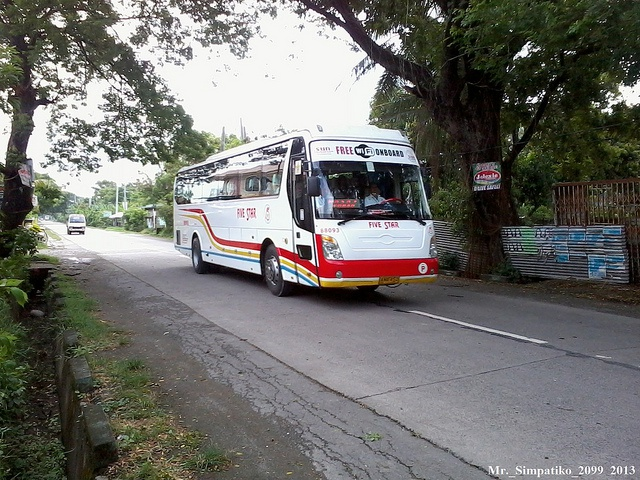Describe the objects in this image and their specific colors. I can see bus in gray, lightgray, black, and darkgray tones, truck in gray, white, darkgray, and black tones, and people in gray, black, and darkgray tones in this image. 